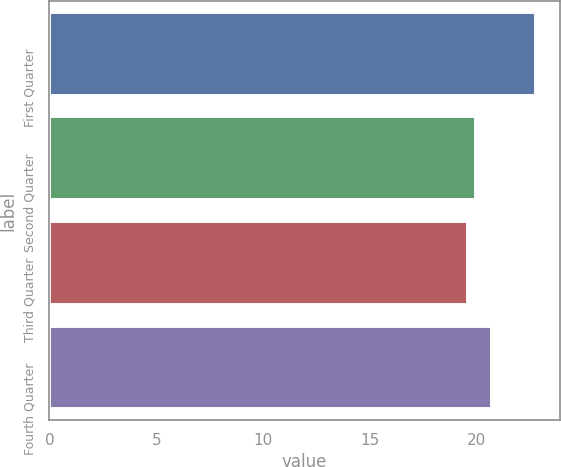Convert chart to OTSL. <chart><loc_0><loc_0><loc_500><loc_500><bar_chart><fcel>First Quarter<fcel>Second Quarter<fcel>Third Quarter<fcel>Fourth Quarter<nl><fcel>22.75<fcel>19.97<fcel>19.59<fcel>20.7<nl></chart> 